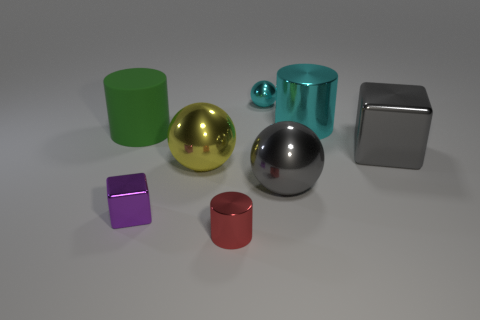Does the large cylinder that is to the right of the big yellow metallic thing have the same color as the small metallic ball?
Your answer should be very brief. Yes. The tiny cube has what color?
Your answer should be compact. Purple. Do the cylinder behind the green rubber object and the small cyan metal object have the same size?
Ensure brevity in your answer.  No. The small purple shiny thing has what shape?
Give a very brief answer. Cube. What is the size of the shiny sphere that is the same color as the big metal cylinder?
Provide a succinct answer. Small. Is the material of the cylinder that is to the left of the small purple shiny block the same as the large yellow sphere?
Offer a very short reply. No. Is there a big thing that has the same color as the small metallic ball?
Your response must be concise. Yes. There is a gray metallic object on the right side of the gray sphere; is its shape the same as the cyan shiny thing that is behind the large cyan cylinder?
Your answer should be compact. No. Is there a large yellow ball that has the same material as the purple cube?
Ensure brevity in your answer.  Yes. How many cyan things are either shiny spheres or large rubber blocks?
Provide a short and direct response. 1. 